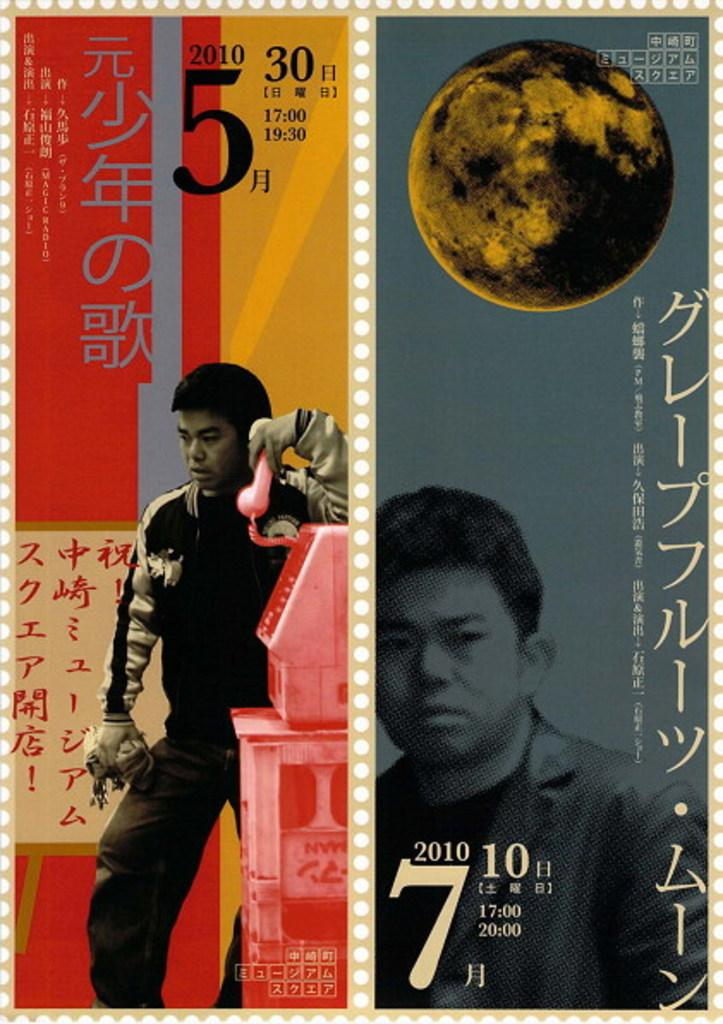<image>
Present a compact description of the photo's key features. Asian stamp with 7 2010 in the corner and a asian mans picture. 